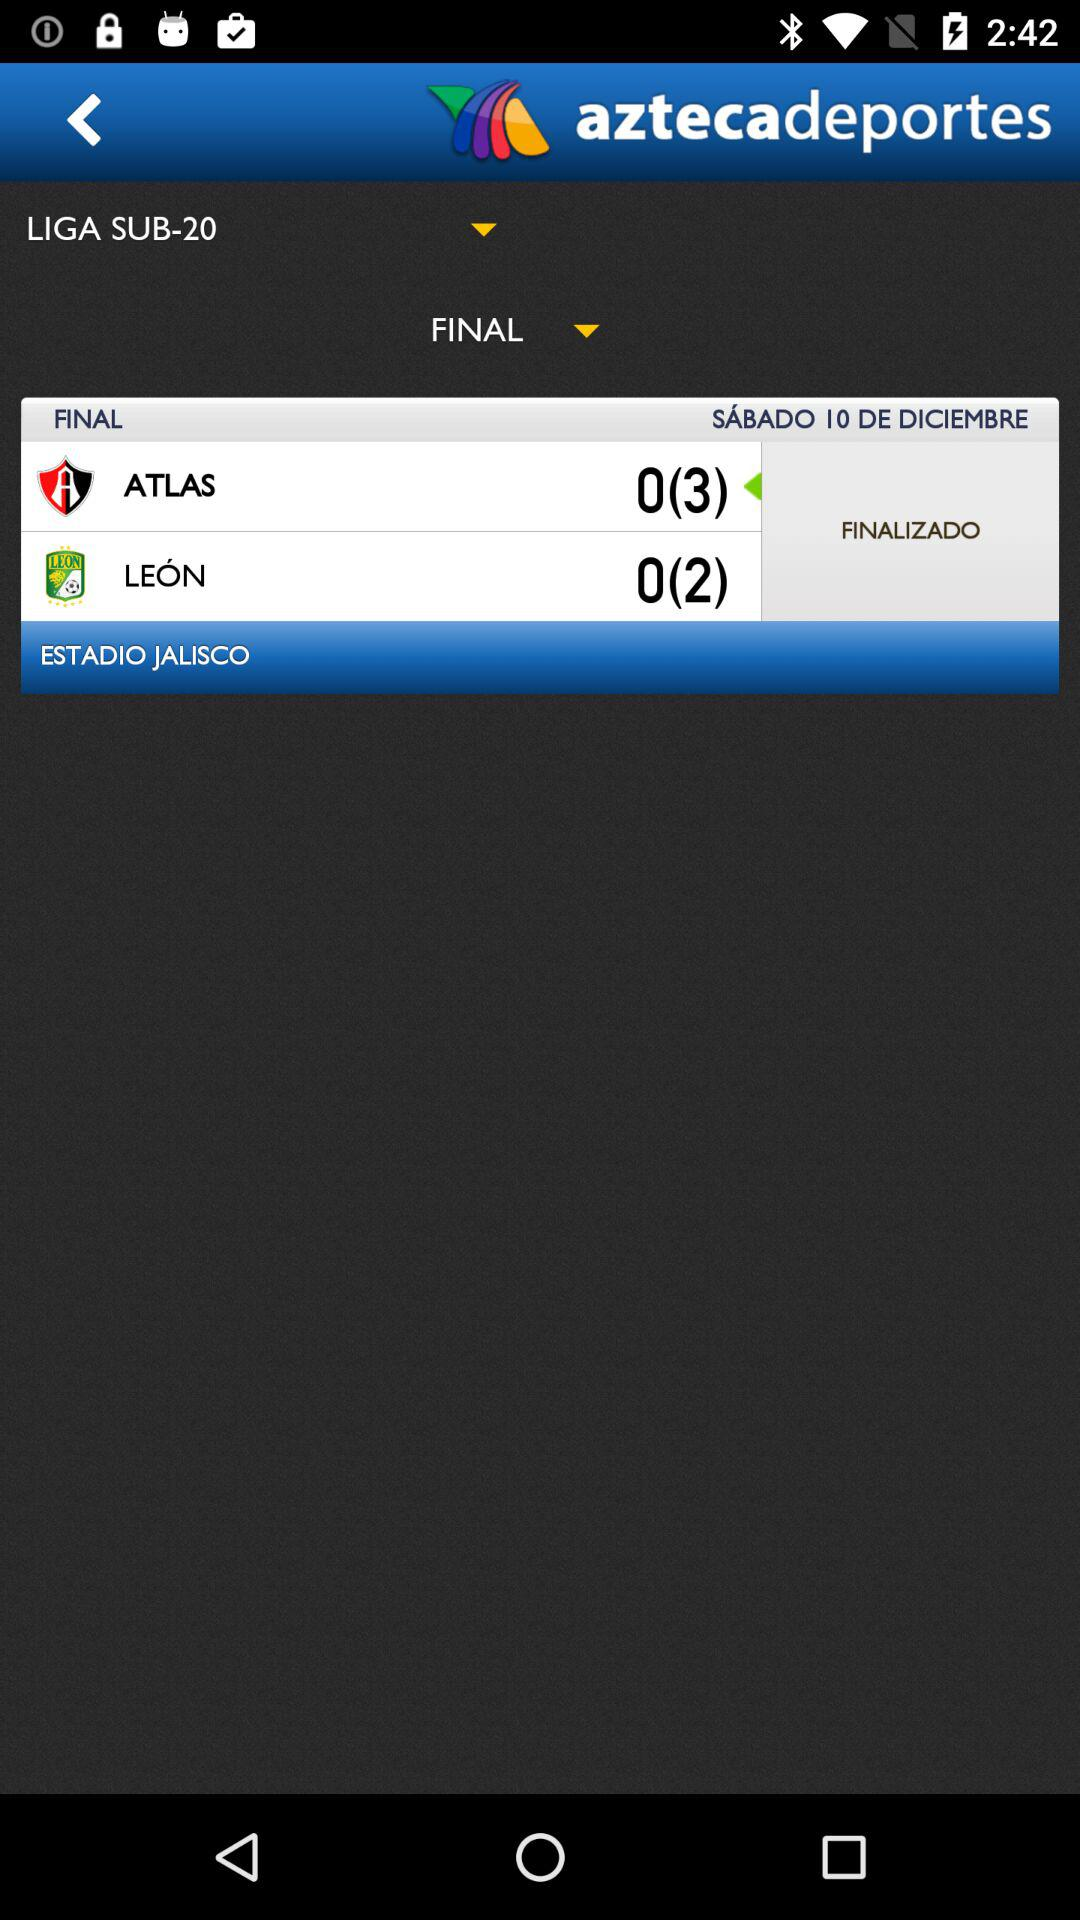How many teams are playing in the match?
Answer the question using a single word or phrase. 2 